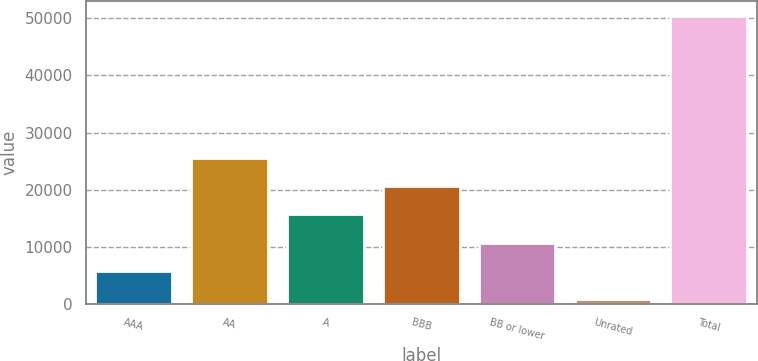Convert chart to OTSL. <chart><loc_0><loc_0><loc_500><loc_500><bar_chart><fcel>AAA<fcel>AA<fcel>A<fcel>BBB<fcel>BB or lower<fcel>Unrated<fcel>Total<nl><fcel>5759<fcel>25611<fcel>15685<fcel>20648<fcel>10722<fcel>796<fcel>50426<nl></chart> 